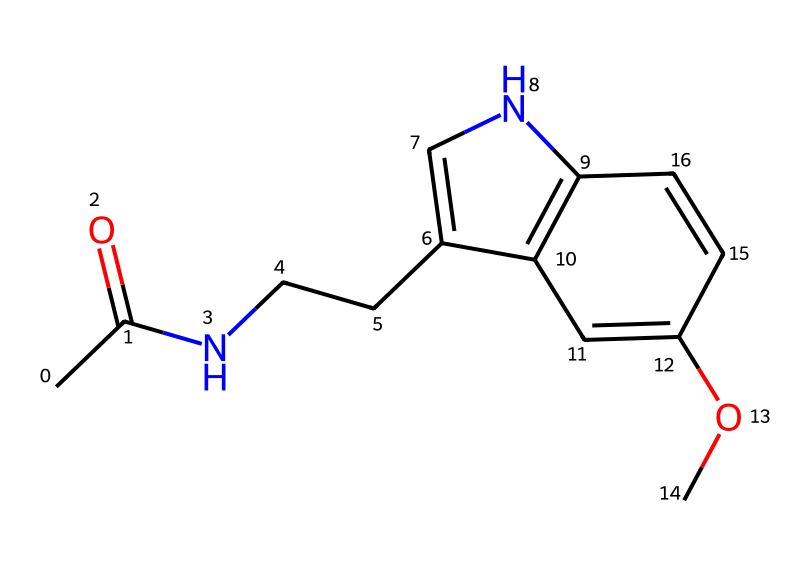What is the molecular formula of melatonin based on its structure? The molecular formula can be derived from counting all the carbon, hydrogen, nitrogen, and oxygen atoms in the SMILES representation. In this case, the total count yields C13H16N2O2.
Answer: C13H16N2O2 How many nitrogen atoms are present in the structure? In the SMILES representation, there are two 'N' symbols, indicating the presence of two nitrogen atoms in the structure.
Answer: 2 What functional groups are present in melatonin? By analyzing the structure, we can see that there is an amide group (due to the nitrogen attached to the carbonyl carbon) and a methoxy group (due to the -OCH3 fragment), indicating the types of functional groups present.
Answer: amide and methoxy What is the significance of the indole structure in melatonin? The indole structure contributes to the bioactivity, particularly in relation to its role in sleep regulation and its interaction with melatonin receptors, which is crucial for its function as a hormone.
Answer: bioactivity Is melatonin considered a neurotransmitter? Yes, melatonin regulates sleep-wake cycles and is often classified as a neurohormone because it plays a role in signaling within the central nervous system.
Answer: yes 